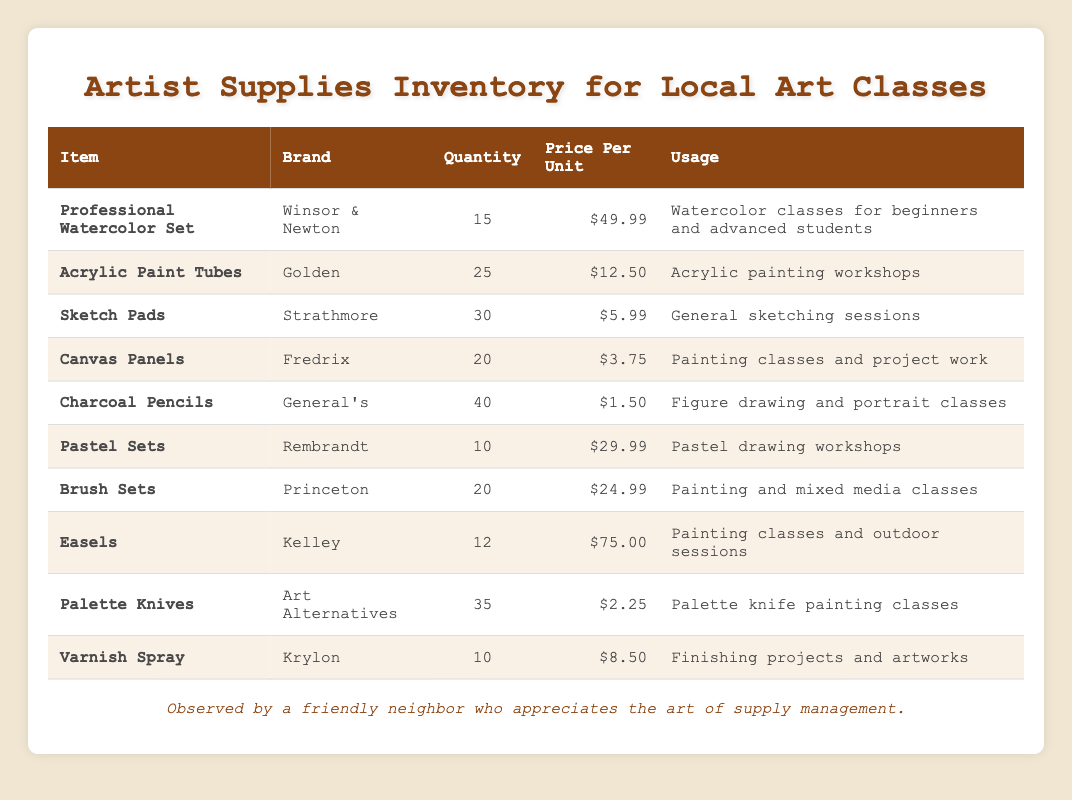What is the total quantity of Charcoal Pencils available? The table lists the quantity of Charcoal Pencils as 40.
Answer: 40 Which item has the highest price per unit? The highest price per unit listed is for the Easels at $75.00.
Answer: Easels How many more Acrylic Paint Tubes are there than Professional Watercolor Sets? The quantity of Acrylic Paint Tubes is 25, and the quantity of Professional Watercolor Sets is 15. The difference is 25 - 15 = 10.
Answer: 10 Is there a higher quantity of Sketch Pads or Pastel Sets? Sketch Pads have a quantity of 30, while Pastel Sets have a quantity of 10. Therefore, Sketch Pads have a higher quantity.
Answer: Sketch Pads What is the total cost of purchasing all quantities of Canvas Panels? The price per unit of Canvas Panels is $3.75. With a quantity of 20, the total cost is 20 * 3.75 = $75.00.
Answer: $75.00 How many items are listed in the inventory? There are 10 different items listed in the inventory table.
Answer: 10 What is the average price per unit of all the items? The total price per unit sums up to 49.99 + 12.50 + 5.99 + 3.75 + 1.50 + 29.99 + 24.99 + 75.00 + 2.25 + 8.50 =  208.47. The average is 208.47 / 10 = 20.85.
Answer: $20.85 How many items have a quantity of more than 20? The items with quantities greater than 20 are Acrylic Paint Tubes (25), Sketch Pads (30), Charcoal Pencils (40), and Palette Knives (35). Thus, there are 4 items.
Answer: 4 What is the total quantity of supplies in the inventory? Summing the quantities gives: 15 + 25 + 30 + 20 + 40 + 10 + 20 + 12 + 35 + 10 =  227.
Answer: 227 Are there any items used for pastel drawing workshops? Yes, there are Pastel Sets used for pastel drawing workshops, with a quantity of 10.
Answer: Yes 